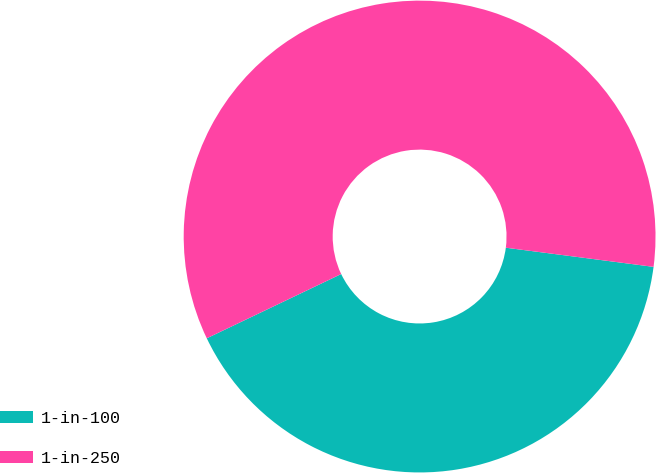Convert chart. <chart><loc_0><loc_0><loc_500><loc_500><pie_chart><fcel>1-in-100<fcel>1-in-250<nl><fcel>40.85%<fcel>59.15%<nl></chart> 